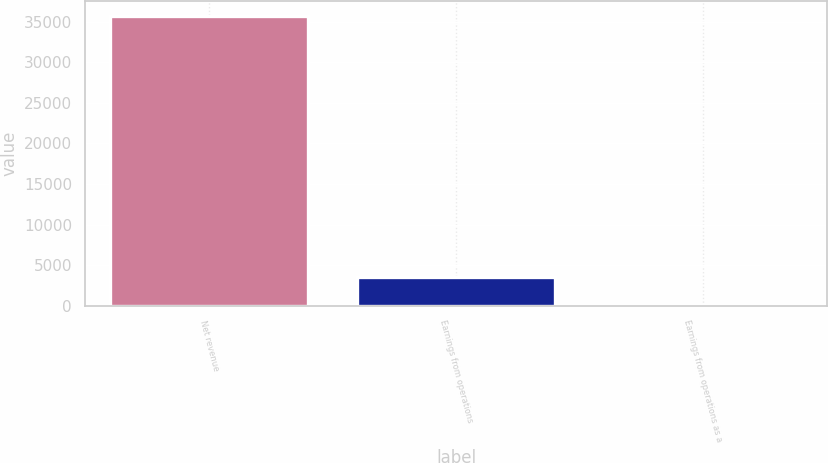<chart> <loc_0><loc_0><loc_500><loc_500><bar_chart><fcel>Net revenue<fcel>Earnings from operations<fcel>Earnings from operations as a<nl><fcel>35725<fcel>3576.73<fcel>4.7<nl></chart> 